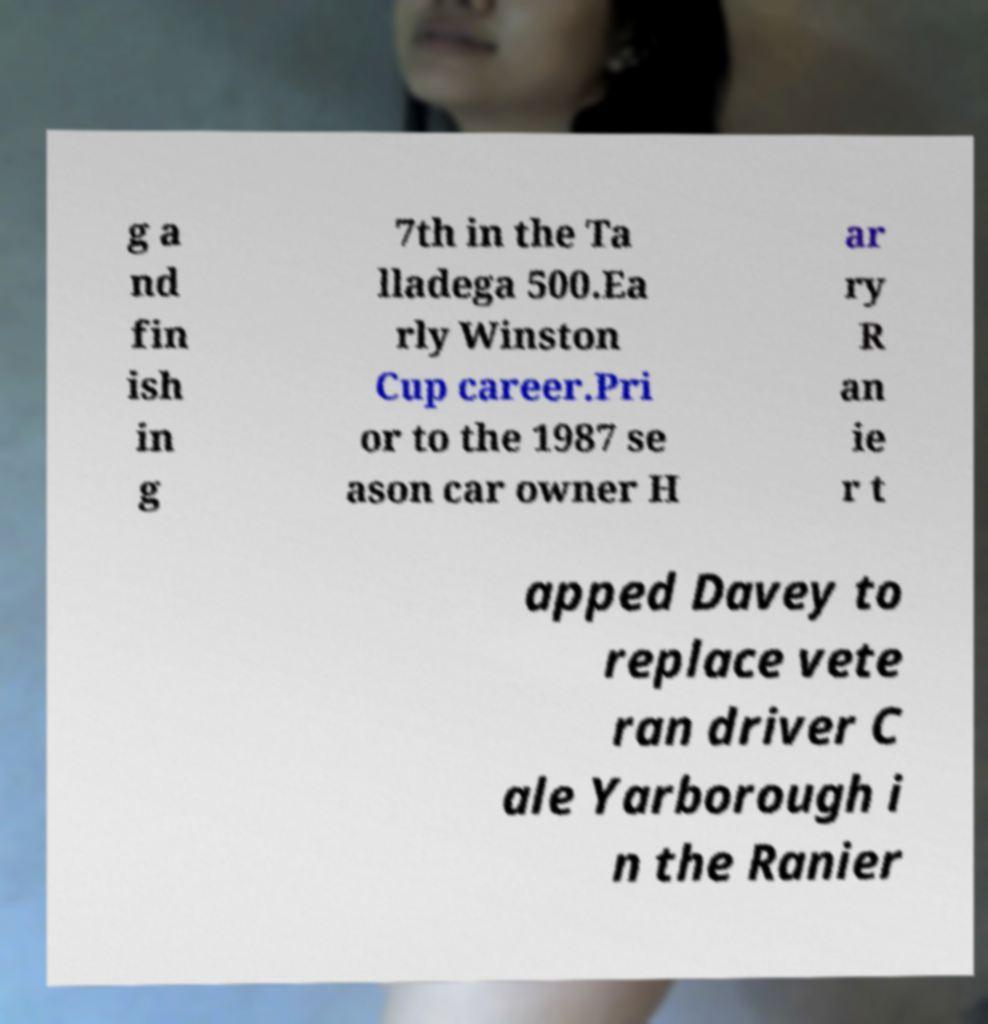Can you accurately transcribe the text from the provided image for me? g a nd fin ish in g 7th in the Ta lladega 500.Ea rly Winston Cup career.Pri or to the 1987 se ason car owner H ar ry R an ie r t apped Davey to replace vete ran driver C ale Yarborough i n the Ranier 